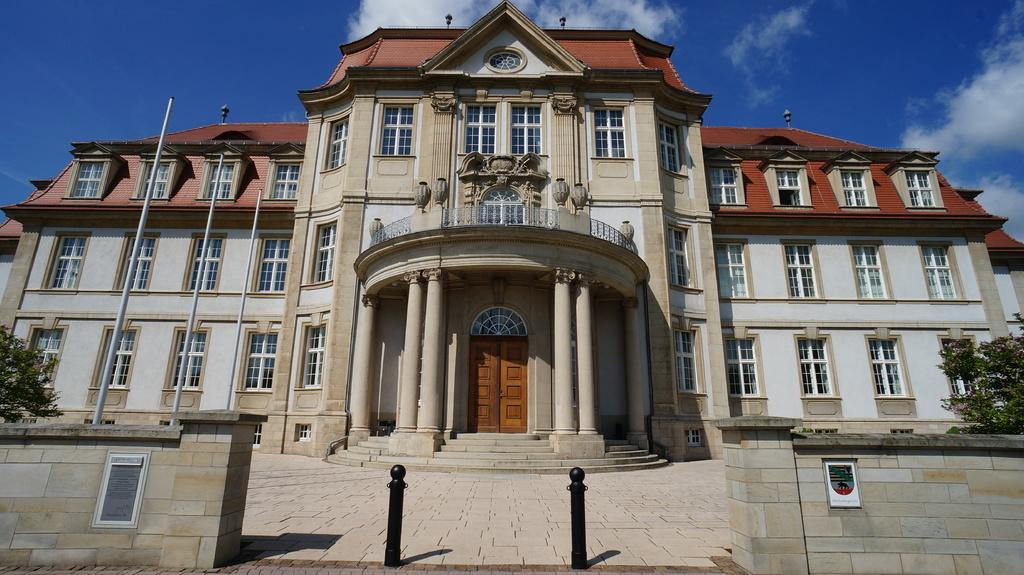What type of structure is present in the image? There is a building in the image. What else can be seen in the image besides the building? There are poles and trees visible in the image. What is visible in the background of the image? The sky is visible in the background of the image. What type of zinc can be seen on the coast in the image? There is no zinc or coast present in the image; it features a building, poles, trees, and the sky. Which type of berry is growing on the trees in the image? There is no mention of berries or any specific type of tree in the image, so we cannot determine if any berries are growing on the trees. 